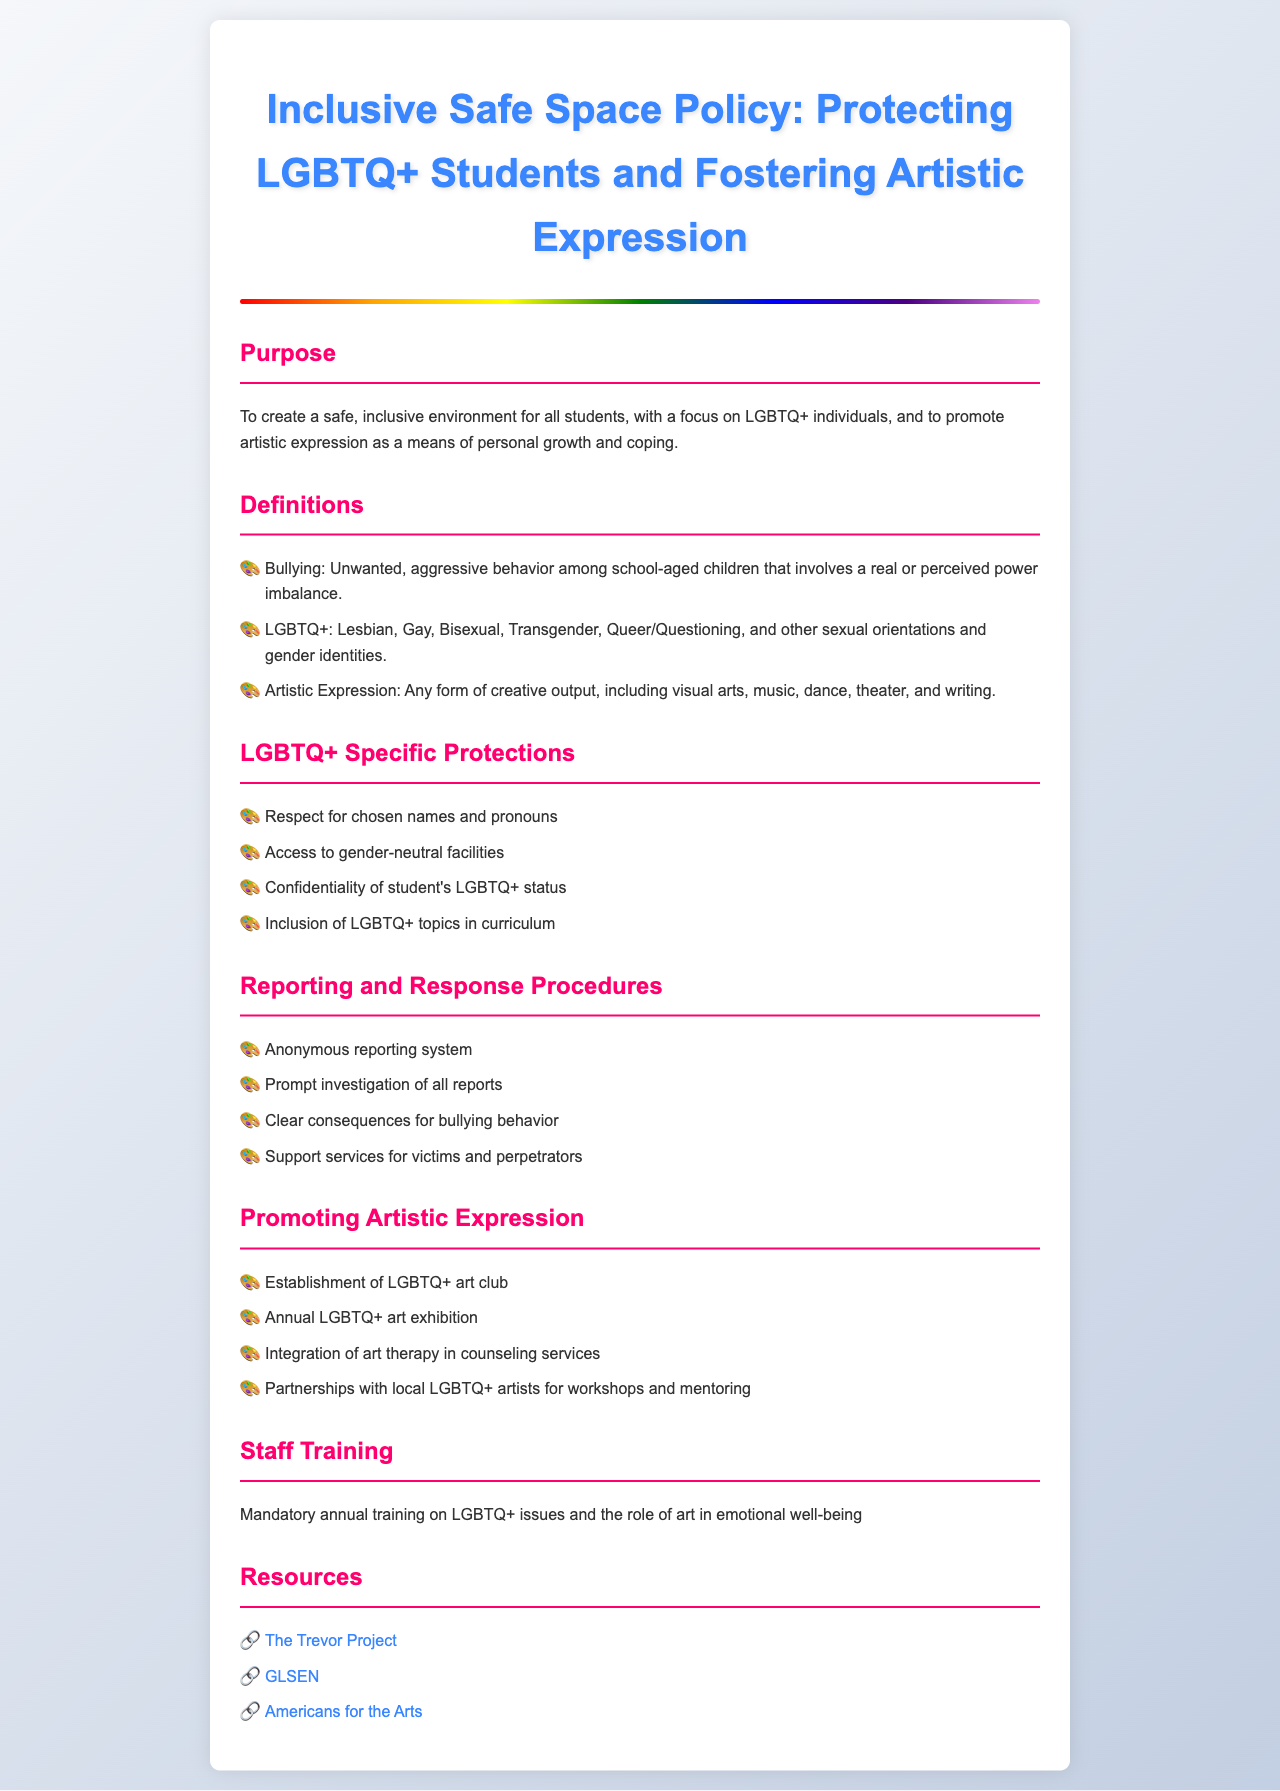What is the purpose of the policy? The purpose outlines the goal of creating a safe, inclusive environment, focusing on LGBTQ+ individuals, and promoting artistic expression.
Answer: To create a safe, inclusive environment for all students, with a focus on LGBTQ+ individuals, and to promote artistic expression as a means of personal growth and coping What is included in LGBTQ+ specific protections? This information details provisions specified for the protection of LGBTQ+ students in the document.
Answer: Respect for chosen names and pronouns What is the main type of artistic initiative mentioned? This question targets specific programs aimed at promoting artistic expression included in the policy.
Answer: LGBTQ+ art club What does the reporting system allow? The information focuses on the capabilities of the reporting system designed for the students.
Answer: Anonymous reporting system How often is staff training mandated? The question seeks information regarding the frequency of required training sessions outlined in the document.
Answer: Mandatory annual training What type of counseling service is integrated? This highlights an artistic initiative that merges therapeutic approaches with counseling.
Answer: Art therapy What is the key focus of the purpose section? The question examines the main aspects addressed in the purpose section to ensure clarity and inclusivity.
Answer: Safe, inclusive environment What types of professionals are mentioned for workshops and mentoring? The question seeks to identify specific individuals that will provide support to students through artistic programs.
Answer: Local LGBTQ+ artists What organization is mentioned for LGBTQ+ resource support? This requests the name of a specific organization included in the resources section of the document.
Answer: The Trevor Project 